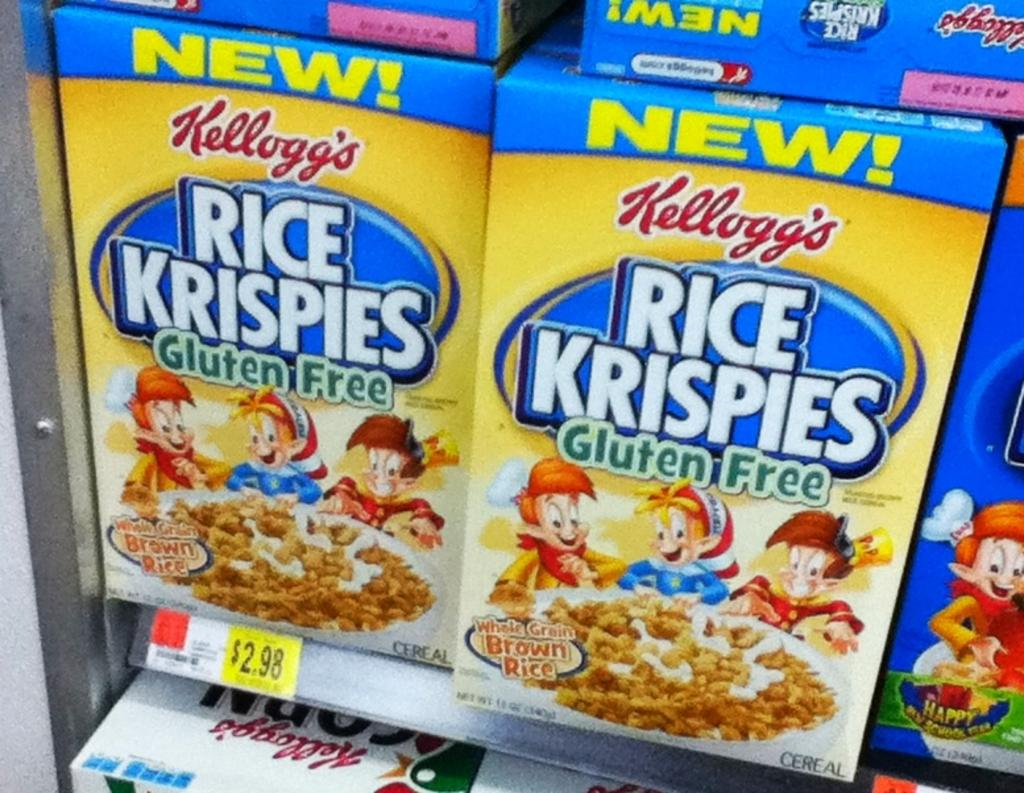What type of product packaging is visible in the image? There are Kellogg's boxes in the image. What type of cloth is draped over the Kellogg's boxes in the image? There is no cloth draped over the Kellogg's boxes in the image. What scientific theory is being discussed in relation to the Kellogg's boxes in the image? There is no scientific theory being discussed in relation to the Kellogg's boxes in the image. 